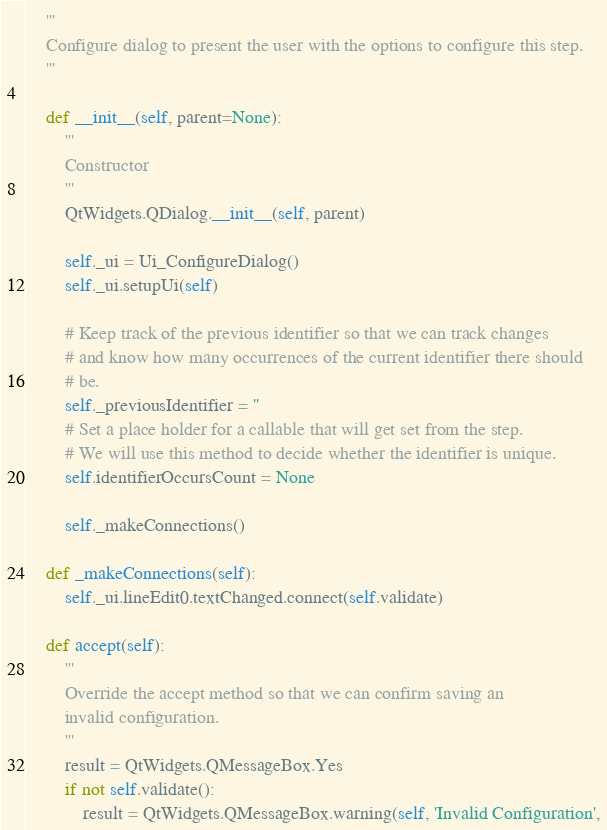Convert code to text. <code><loc_0><loc_0><loc_500><loc_500><_Python_>    '''
    Configure dialog to present the user with the options to configure this step.
    '''

    def __init__(self, parent=None):
        '''
        Constructor
        '''
        QtWidgets.QDialog.__init__(self, parent)

        self._ui = Ui_ConfigureDialog()
        self._ui.setupUi(self)

        # Keep track of the previous identifier so that we can track changes
        # and know how many occurrences of the current identifier there should
        # be.
        self._previousIdentifier = ''
        # Set a place holder for a callable that will get set from the step.
        # We will use this method to decide whether the identifier is unique.
        self.identifierOccursCount = None

        self._makeConnections()

    def _makeConnections(self):
        self._ui.lineEdit0.textChanged.connect(self.validate)

    def accept(self):
        '''
        Override the accept method so that we can confirm saving an
        invalid configuration.
        '''
        result = QtWidgets.QMessageBox.Yes
        if not self.validate():
            result = QtWidgets.QMessageBox.warning(self, 'Invalid Configuration',</code> 